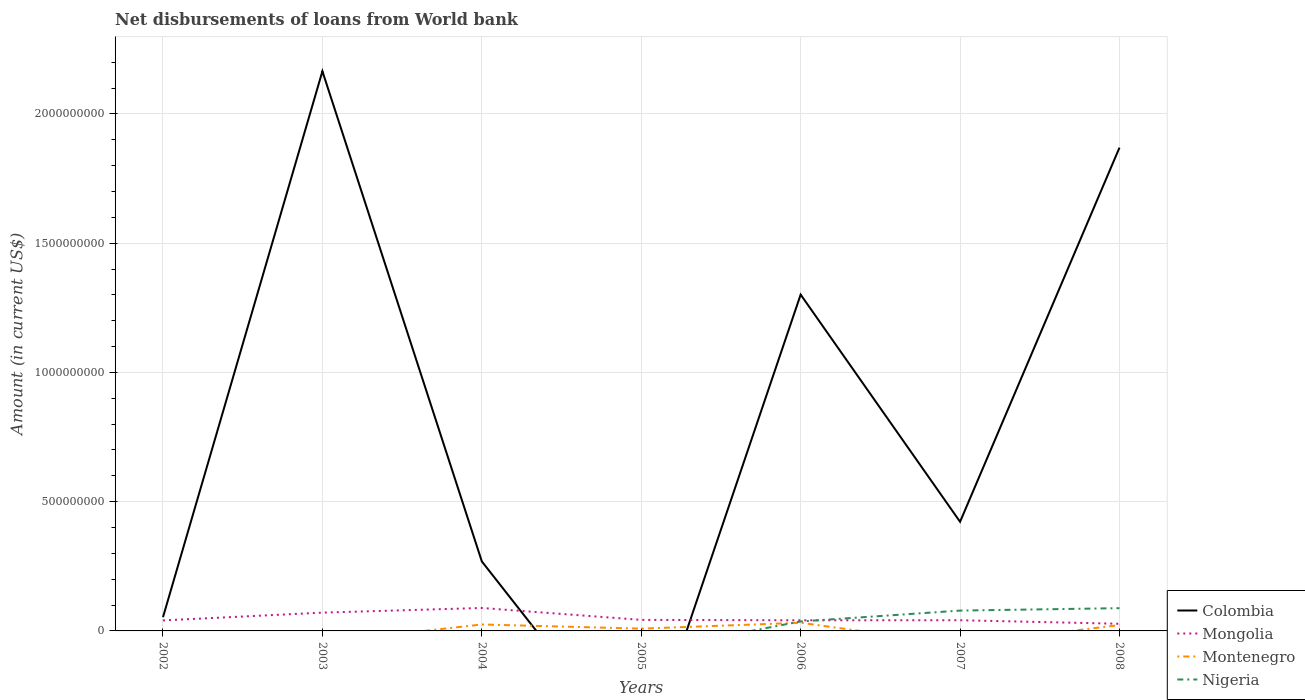Is the number of lines equal to the number of legend labels?
Ensure brevity in your answer.  No. What is the total amount of loan disbursed from World Bank in Colombia in the graph?
Your answer should be compact. -1.60e+09. What is the difference between the highest and the second highest amount of loan disbursed from World Bank in Nigeria?
Ensure brevity in your answer.  8.80e+07. What is the difference between the highest and the lowest amount of loan disbursed from World Bank in Colombia?
Your answer should be compact. 3. Are the values on the major ticks of Y-axis written in scientific E-notation?
Provide a succinct answer. No. Does the graph contain any zero values?
Make the answer very short. Yes. Does the graph contain grids?
Keep it short and to the point. Yes. Where does the legend appear in the graph?
Offer a terse response. Bottom right. How many legend labels are there?
Keep it short and to the point. 4. What is the title of the graph?
Give a very brief answer. Net disbursements of loans from World bank. Does "High income: OECD" appear as one of the legend labels in the graph?
Offer a terse response. No. What is the label or title of the X-axis?
Ensure brevity in your answer.  Years. What is the Amount (in current US$) in Colombia in 2002?
Your answer should be very brief. 5.33e+07. What is the Amount (in current US$) in Mongolia in 2002?
Offer a very short reply. 4.07e+07. What is the Amount (in current US$) in Nigeria in 2002?
Offer a very short reply. 0. What is the Amount (in current US$) of Colombia in 2003?
Offer a very short reply. 2.17e+09. What is the Amount (in current US$) in Mongolia in 2003?
Your answer should be very brief. 7.08e+07. What is the Amount (in current US$) in Nigeria in 2003?
Offer a very short reply. 0. What is the Amount (in current US$) in Colombia in 2004?
Provide a succinct answer. 2.69e+08. What is the Amount (in current US$) in Mongolia in 2004?
Your answer should be very brief. 8.88e+07. What is the Amount (in current US$) in Montenegro in 2004?
Ensure brevity in your answer.  2.50e+07. What is the Amount (in current US$) of Nigeria in 2004?
Give a very brief answer. 0. What is the Amount (in current US$) of Colombia in 2005?
Give a very brief answer. 0. What is the Amount (in current US$) in Mongolia in 2005?
Your answer should be very brief. 4.27e+07. What is the Amount (in current US$) in Montenegro in 2005?
Provide a succinct answer. 8.81e+06. What is the Amount (in current US$) in Nigeria in 2005?
Provide a succinct answer. 0. What is the Amount (in current US$) in Colombia in 2006?
Provide a short and direct response. 1.30e+09. What is the Amount (in current US$) of Mongolia in 2006?
Your response must be concise. 4.11e+07. What is the Amount (in current US$) in Montenegro in 2006?
Offer a very short reply. 3.16e+07. What is the Amount (in current US$) in Nigeria in 2006?
Ensure brevity in your answer.  3.66e+07. What is the Amount (in current US$) in Colombia in 2007?
Your answer should be very brief. 4.22e+08. What is the Amount (in current US$) of Mongolia in 2007?
Your answer should be compact. 4.14e+07. What is the Amount (in current US$) in Montenegro in 2007?
Provide a short and direct response. 0. What is the Amount (in current US$) of Nigeria in 2007?
Your answer should be compact. 7.87e+07. What is the Amount (in current US$) of Colombia in 2008?
Your answer should be compact. 1.87e+09. What is the Amount (in current US$) in Mongolia in 2008?
Ensure brevity in your answer.  2.77e+07. What is the Amount (in current US$) in Montenegro in 2008?
Provide a short and direct response. 2.27e+07. What is the Amount (in current US$) in Nigeria in 2008?
Offer a terse response. 8.80e+07. Across all years, what is the maximum Amount (in current US$) in Colombia?
Make the answer very short. 2.17e+09. Across all years, what is the maximum Amount (in current US$) of Mongolia?
Provide a succinct answer. 8.88e+07. Across all years, what is the maximum Amount (in current US$) of Montenegro?
Provide a succinct answer. 3.16e+07. Across all years, what is the maximum Amount (in current US$) of Nigeria?
Ensure brevity in your answer.  8.80e+07. Across all years, what is the minimum Amount (in current US$) in Mongolia?
Keep it short and to the point. 2.77e+07. Across all years, what is the minimum Amount (in current US$) of Montenegro?
Your answer should be very brief. 0. What is the total Amount (in current US$) of Colombia in the graph?
Ensure brevity in your answer.  6.08e+09. What is the total Amount (in current US$) of Mongolia in the graph?
Provide a short and direct response. 3.53e+08. What is the total Amount (in current US$) of Montenegro in the graph?
Offer a terse response. 8.80e+07. What is the total Amount (in current US$) in Nigeria in the graph?
Your response must be concise. 2.03e+08. What is the difference between the Amount (in current US$) in Colombia in 2002 and that in 2003?
Your answer should be very brief. -2.11e+09. What is the difference between the Amount (in current US$) of Mongolia in 2002 and that in 2003?
Provide a short and direct response. -3.01e+07. What is the difference between the Amount (in current US$) of Colombia in 2002 and that in 2004?
Provide a short and direct response. -2.16e+08. What is the difference between the Amount (in current US$) of Mongolia in 2002 and that in 2004?
Your answer should be compact. -4.81e+07. What is the difference between the Amount (in current US$) of Mongolia in 2002 and that in 2005?
Make the answer very short. -2.03e+06. What is the difference between the Amount (in current US$) in Colombia in 2002 and that in 2006?
Your response must be concise. -1.25e+09. What is the difference between the Amount (in current US$) of Mongolia in 2002 and that in 2006?
Your response must be concise. -4.18e+05. What is the difference between the Amount (in current US$) of Colombia in 2002 and that in 2007?
Offer a very short reply. -3.69e+08. What is the difference between the Amount (in current US$) of Mongolia in 2002 and that in 2007?
Keep it short and to the point. -6.66e+05. What is the difference between the Amount (in current US$) in Colombia in 2002 and that in 2008?
Your answer should be very brief. -1.82e+09. What is the difference between the Amount (in current US$) in Mongolia in 2002 and that in 2008?
Provide a short and direct response. 1.30e+07. What is the difference between the Amount (in current US$) of Colombia in 2003 and that in 2004?
Your answer should be compact. 1.90e+09. What is the difference between the Amount (in current US$) in Mongolia in 2003 and that in 2004?
Offer a terse response. -1.80e+07. What is the difference between the Amount (in current US$) in Mongolia in 2003 and that in 2005?
Ensure brevity in your answer.  2.80e+07. What is the difference between the Amount (in current US$) of Colombia in 2003 and that in 2006?
Your answer should be very brief. 8.64e+08. What is the difference between the Amount (in current US$) in Mongolia in 2003 and that in 2006?
Offer a very short reply. 2.96e+07. What is the difference between the Amount (in current US$) in Colombia in 2003 and that in 2007?
Make the answer very short. 1.74e+09. What is the difference between the Amount (in current US$) in Mongolia in 2003 and that in 2007?
Offer a terse response. 2.94e+07. What is the difference between the Amount (in current US$) in Colombia in 2003 and that in 2008?
Your answer should be compact. 2.96e+08. What is the difference between the Amount (in current US$) in Mongolia in 2003 and that in 2008?
Keep it short and to the point. 4.31e+07. What is the difference between the Amount (in current US$) in Mongolia in 2004 and that in 2005?
Offer a terse response. 4.61e+07. What is the difference between the Amount (in current US$) in Montenegro in 2004 and that in 2005?
Your answer should be compact. 1.61e+07. What is the difference between the Amount (in current US$) of Colombia in 2004 and that in 2006?
Offer a terse response. -1.03e+09. What is the difference between the Amount (in current US$) in Mongolia in 2004 and that in 2006?
Provide a short and direct response. 4.77e+07. What is the difference between the Amount (in current US$) of Montenegro in 2004 and that in 2006?
Provide a short and direct response. -6.62e+06. What is the difference between the Amount (in current US$) of Colombia in 2004 and that in 2007?
Keep it short and to the point. -1.53e+08. What is the difference between the Amount (in current US$) in Mongolia in 2004 and that in 2007?
Your response must be concise. 4.74e+07. What is the difference between the Amount (in current US$) in Colombia in 2004 and that in 2008?
Your response must be concise. -1.60e+09. What is the difference between the Amount (in current US$) in Mongolia in 2004 and that in 2008?
Ensure brevity in your answer.  6.11e+07. What is the difference between the Amount (in current US$) in Montenegro in 2004 and that in 2008?
Make the answer very short. 2.25e+06. What is the difference between the Amount (in current US$) of Mongolia in 2005 and that in 2006?
Give a very brief answer. 1.62e+06. What is the difference between the Amount (in current US$) of Montenegro in 2005 and that in 2006?
Keep it short and to the point. -2.28e+07. What is the difference between the Amount (in current US$) in Mongolia in 2005 and that in 2007?
Your response must be concise. 1.37e+06. What is the difference between the Amount (in current US$) in Mongolia in 2005 and that in 2008?
Offer a very short reply. 1.51e+07. What is the difference between the Amount (in current US$) in Montenegro in 2005 and that in 2008?
Your answer should be very brief. -1.39e+07. What is the difference between the Amount (in current US$) of Colombia in 2006 and that in 2007?
Your response must be concise. 8.79e+08. What is the difference between the Amount (in current US$) of Mongolia in 2006 and that in 2007?
Your answer should be very brief. -2.48e+05. What is the difference between the Amount (in current US$) in Nigeria in 2006 and that in 2007?
Make the answer very short. -4.21e+07. What is the difference between the Amount (in current US$) of Colombia in 2006 and that in 2008?
Offer a terse response. -5.69e+08. What is the difference between the Amount (in current US$) in Mongolia in 2006 and that in 2008?
Your response must be concise. 1.34e+07. What is the difference between the Amount (in current US$) of Montenegro in 2006 and that in 2008?
Offer a terse response. 8.87e+06. What is the difference between the Amount (in current US$) in Nigeria in 2006 and that in 2008?
Make the answer very short. -5.14e+07. What is the difference between the Amount (in current US$) in Colombia in 2007 and that in 2008?
Your answer should be very brief. -1.45e+09. What is the difference between the Amount (in current US$) in Mongolia in 2007 and that in 2008?
Make the answer very short. 1.37e+07. What is the difference between the Amount (in current US$) of Nigeria in 2007 and that in 2008?
Keep it short and to the point. -9.36e+06. What is the difference between the Amount (in current US$) in Colombia in 2002 and the Amount (in current US$) in Mongolia in 2003?
Offer a terse response. -1.74e+07. What is the difference between the Amount (in current US$) in Colombia in 2002 and the Amount (in current US$) in Mongolia in 2004?
Your answer should be very brief. -3.55e+07. What is the difference between the Amount (in current US$) of Colombia in 2002 and the Amount (in current US$) of Montenegro in 2004?
Make the answer very short. 2.84e+07. What is the difference between the Amount (in current US$) in Mongolia in 2002 and the Amount (in current US$) in Montenegro in 2004?
Make the answer very short. 1.57e+07. What is the difference between the Amount (in current US$) in Colombia in 2002 and the Amount (in current US$) in Mongolia in 2005?
Make the answer very short. 1.06e+07. What is the difference between the Amount (in current US$) in Colombia in 2002 and the Amount (in current US$) in Montenegro in 2005?
Offer a terse response. 4.45e+07. What is the difference between the Amount (in current US$) of Mongolia in 2002 and the Amount (in current US$) of Montenegro in 2005?
Give a very brief answer. 3.19e+07. What is the difference between the Amount (in current US$) in Colombia in 2002 and the Amount (in current US$) in Mongolia in 2006?
Your answer should be very brief. 1.22e+07. What is the difference between the Amount (in current US$) of Colombia in 2002 and the Amount (in current US$) of Montenegro in 2006?
Your answer should be compact. 2.17e+07. What is the difference between the Amount (in current US$) in Colombia in 2002 and the Amount (in current US$) in Nigeria in 2006?
Give a very brief answer. 1.67e+07. What is the difference between the Amount (in current US$) of Mongolia in 2002 and the Amount (in current US$) of Montenegro in 2006?
Keep it short and to the point. 9.12e+06. What is the difference between the Amount (in current US$) of Mongolia in 2002 and the Amount (in current US$) of Nigeria in 2006?
Keep it short and to the point. 4.08e+06. What is the difference between the Amount (in current US$) in Colombia in 2002 and the Amount (in current US$) in Mongolia in 2007?
Your answer should be compact. 1.20e+07. What is the difference between the Amount (in current US$) in Colombia in 2002 and the Amount (in current US$) in Nigeria in 2007?
Your response must be concise. -2.54e+07. What is the difference between the Amount (in current US$) in Mongolia in 2002 and the Amount (in current US$) in Nigeria in 2007?
Your answer should be compact. -3.80e+07. What is the difference between the Amount (in current US$) of Colombia in 2002 and the Amount (in current US$) of Mongolia in 2008?
Provide a short and direct response. 2.57e+07. What is the difference between the Amount (in current US$) of Colombia in 2002 and the Amount (in current US$) of Montenegro in 2008?
Keep it short and to the point. 3.06e+07. What is the difference between the Amount (in current US$) in Colombia in 2002 and the Amount (in current US$) in Nigeria in 2008?
Provide a succinct answer. -3.47e+07. What is the difference between the Amount (in current US$) in Mongolia in 2002 and the Amount (in current US$) in Montenegro in 2008?
Your answer should be compact. 1.80e+07. What is the difference between the Amount (in current US$) of Mongolia in 2002 and the Amount (in current US$) of Nigeria in 2008?
Your response must be concise. -4.74e+07. What is the difference between the Amount (in current US$) in Colombia in 2003 and the Amount (in current US$) in Mongolia in 2004?
Keep it short and to the point. 2.08e+09. What is the difference between the Amount (in current US$) of Colombia in 2003 and the Amount (in current US$) of Montenegro in 2004?
Provide a succinct answer. 2.14e+09. What is the difference between the Amount (in current US$) in Mongolia in 2003 and the Amount (in current US$) in Montenegro in 2004?
Your response must be concise. 4.58e+07. What is the difference between the Amount (in current US$) in Colombia in 2003 and the Amount (in current US$) in Mongolia in 2005?
Your answer should be very brief. 2.12e+09. What is the difference between the Amount (in current US$) of Colombia in 2003 and the Amount (in current US$) of Montenegro in 2005?
Make the answer very short. 2.16e+09. What is the difference between the Amount (in current US$) in Mongolia in 2003 and the Amount (in current US$) in Montenegro in 2005?
Keep it short and to the point. 6.20e+07. What is the difference between the Amount (in current US$) in Colombia in 2003 and the Amount (in current US$) in Mongolia in 2006?
Provide a short and direct response. 2.12e+09. What is the difference between the Amount (in current US$) of Colombia in 2003 and the Amount (in current US$) of Montenegro in 2006?
Your answer should be very brief. 2.13e+09. What is the difference between the Amount (in current US$) in Colombia in 2003 and the Amount (in current US$) in Nigeria in 2006?
Provide a succinct answer. 2.13e+09. What is the difference between the Amount (in current US$) of Mongolia in 2003 and the Amount (in current US$) of Montenegro in 2006?
Keep it short and to the point. 3.92e+07. What is the difference between the Amount (in current US$) of Mongolia in 2003 and the Amount (in current US$) of Nigeria in 2006?
Your answer should be very brief. 3.41e+07. What is the difference between the Amount (in current US$) of Colombia in 2003 and the Amount (in current US$) of Mongolia in 2007?
Your response must be concise. 2.12e+09. What is the difference between the Amount (in current US$) of Colombia in 2003 and the Amount (in current US$) of Nigeria in 2007?
Your answer should be very brief. 2.09e+09. What is the difference between the Amount (in current US$) of Mongolia in 2003 and the Amount (in current US$) of Nigeria in 2007?
Make the answer very short. -7.93e+06. What is the difference between the Amount (in current US$) of Colombia in 2003 and the Amount (in current US$) of Mongolia in 2008?
Provide a short and direct response. 2.14e+09. What is the difference between the Amount (in current US$) of Colombia in 2003 and the Amount (in current US$) of Montenegro in 2008?
Keep it short and to the point. 2.14e+09. What is the difference between the Amount (in current US$) in Colombia in 2003 and the Amount (in current US$) in Nigeria in 2008?
Your response must be concise. 2.08e+09. What is the difference between the Amount (in current US$) in Mongolia in 2003 and the Amount (in current US$) in Montenegro in 2008?
Provide a short and direct response. 4.81e+07. What is the difference between the Amount (in current US$) in Mongolia in 2003 and the Amount (in current US$) in Nigeria in 2008?
Offer a very short reply. -1.73e+07. What is the difference between the Amount (in current US$) in Colombia in 2004 and the Amount (in current US$) in Mongolia in 2005?
Give a very brief answer. 2.26e+08. What is the difference between the Amount (in current US$) of Colombia in 2004 and the Amount (in current US$) of Montenegro in 2005?
Your answer should be compact. 2.60e+08. What is the difference between the Amount (in current US$) in Mongolia in 2004 and the Amount (in current US$) in Montenegro in 2005?
Offer a very short reply. 8.00e+07. What is the difference between the Amount (in current US$) of Colombia in 2004 and the Amount (in current US$) of Mongolia in 2006?
Offer a terse response. 2.28e+08. What is the difference between the Amount (in current US$) in Colombia in 2004 and the Amount (in current US$) in Montenegro in 2006?
Offer a very short reply. 2.37e+08. What is the difference between the Amount (in current US$) in Colombia in 2004 and the Amount (in current US$) in Nigeria in 2006?
Keep it short and to the point. 2.32e+08. What is the difference between the Amount (in current US$) in Mongolia in 2004 and the Amount (in current US$) in Montenegro in 2006?
Give a very brief answer. 5.72e+07. What is the difference between the Amount (in current US$) of Mongolia in 2004 and the Amount (in current US$) of Nigeria in 2006?
Keep it short and to the point. 5.22e+07. What is the difference between the Amount (in current US$) of Montenegro in 2004 and the Amount (in current US$) of Nigeria in 2006?
Provide a succinct answer. -1.17e+07. What is the difference between the Amount (in current US$) of Colombia in 2004 and the Amount (in current US$) of Mongolia in 2007?
Keep it short and to the point. 2.28e+08. What is the difference between the Amount (in current US$) in Colombia in 2004 and the Amount (in current US$) in Nigeria in 2007?
Your answer should be very brief. 1.90e+08. What is the difference between the Amount (in current US$) of Mongolia in 2004 and the Amount (in current US$) of Nigeria in 2007?
Provide a short and direct response. 1.01e+07. What is the difference between the Amount (in current US$) of Montenegro in 2004 and the Amount (in current US$) of Nigeria in 2007?
Ensure brevity in your answer.  -5.37e+07. What is the difference between the Amount (in current US$) of Colombia in 2004 and the Amount (in current US$) of Mongolia in 2008?
Provide a succinct answer. 2.41e+08. What is the difference between the Amount (in current US$) in Colombia in 2004 and the Amount (in current US$) in Montenegro in 2008?
Offer a terse response. 2.46e+08. What is the difference between the Amount (in current US$) in Colombia in 2004 and the Amount (in current US$) in Nigeria in 2008?
Offer a very short reply. 1.81e+08. What is the difference between the Amount (in current US$) in Mongolia in 2004 and the Amount (in current US$) in Montenegro in 2008?
Make the answer very short. 6.61e+07. What is the difference between the Amount (in current US$) of Mongolia in 2004 and the Amount (in current US$) of Nigeria in 2008?
Your answer should be compact. 7.46e+05. What is the difference between the Amount (in current US$) of Montenegro in 2004 and the Amount (in current US$) of Nigeria in 2008?
Offer a terse response. -6.31e+07. What is the difference between the Amount (in current US$) of Mongolia in 2005 and the Amount (in current US$) of Montenegro in 2006?
Make the answer very short. 1.12e+07. What is the difference between the Amount (in current US$) of Mongolia in 2005 and the Amount (in current US$) of Nigeria in 2006?
Your answer should be compact. 6.12e+06. What is the difference between the Amount (in current US$) in Montenegro in 2005 and the Amount (in current US$) in Nigeria in 2006?
Your answer should be compact. -2.78e+07. What is the difference between the Amount (in current US$) in Mongolia in 2005 and the Amount (in current US$) in Nigeria in 2007?
Ensure brevity in your answer.  -3.60e+07. What is the difference between the Amount (in current US$) in Montenegro in 2005 and the Amount (in current US$) in Nigeria in 2007?
Provide a short and direct response. -6.99e+07. What is the difference between the Amount (in current US$) of Mongolia in 2005 and the Amount (in current US$) of Montenegro in 2008?
Keep it short and to the point. 2.00e+07. What is the difference between the Amount (in current US$) of Mongolia in 2005 and the Amount (in current US$) of Nigeria in 2008?
Offer a very short reply. -4.53e+07. What is the difference between the Amount (in current US$) of Montenegro in 2005 and the Amount (in current US$) of Nigeria in 2008?
Give a very brief answer. -7.92e+07. What is the difference between the Amount (in current US$) in Colombia in 2006 and the Amount (in current US$) in Mongolia in 2007?
Give a very brief answer. 1.26e+09. What is the difference between the Amount (in current US$) of Colombia in 2006 and the Amount (in current US$) of Nigeria in 2007?
Offer a very short reply. 1.22e+09. What is the difference between the Amount (in current US$) in Mongolia in 2006 and the Amount (in current US$) in Nigeria in 2007?
Give a very brief answer. -3.76e+07. What is the difference between the Amount (in current US$) of Montenegro in 2006 and the Amount (in current US$) of Nigeria in 2007?
Your response must be concise. -4.71e+07. What is the difference between the Amount (in current US$) in Colombia in 2006 and the Amount (in current US$) in Mongolia in 2008?
Your response must be concise. 1.27e+09. What is the difference between the Amount (in current US$) in Colombia in 2006 and the Amount (in current US$) in Montenegro in 2008?
Keep it short and to the point. 1.28e+09. What is the difference between the Amount (in current US$) in Colombia in 2006 and the Amount (in current US$) in Nigeria in 2008?
Provide a short and direct response. 1.21e+09. What is the difference between the Amount (in current US$) of Mongolia in 2006 and the Amount (in current US$) of Montenegro in 2008?
Your answer should be compact. 1.84e+07. What is the difference between the Amount (in current US$) in Mongolia in 2006 and the Amount (in current US$) in Nigeria in 2008?
Keep it short and to the point. -4.69e+07. What is the difference between the Amount (in current US$) of Montenegro in 2006 and the Amount (in current US$) of Nigeria in 2008?
Your answer should be compact. -5.65e+07. What is the difference between the Amount (in current US$) in Colombia in 2007 and the Amount (in current US$) in Mongolia in 2008?
Make the answer very short. 3.95e+08. What is the difference between the Amount (in current US$) of Colombia in 2007 and the Amount (in current US$) of Montenegro in 2008?
Keep it short and to the point. 4.00e+08. What is the difference between the Amount (in current US$) in Colombia in 2007 and the Amount (in current US$) in Nigeria in 2008?
Your answer should be compact. 3.34e+08. What is the difference between the Amount (in current US$) in Mongolia in 2007 and the Amount (in current US$) in Montenegro in 2008?
Your answer should be very brief. 1.87e+07. What is the difference between the Amount (in current US$) in Mongolia in 2007 and the Amount (in current US$) in Nigeria in 2008?
Make the answer very short. -4.67e+07. What is the average Amount (in current US$) of Colombia per year?
Provide a short and direct response. 8.69e+08. What is the average Amount (in current US$) of Mongolia per year?
Your response must be concise. 5.04e+07. What is the average Amount (in current US$) in Montenegro per year?
Give a very brief answer. 1.26e+07. What is the average Amount (in current US$) in Nigeria per year?
Your answer should be compact. 2.90e+07. In the year 2002, what is the difference between the Amount (in current US$) of Colombia and Amount (in current US$) of Mongolia?
Offer a terse response. 1.26e+07. In the year 2003, what is the difference between the Amount (in current US$) of Colombia and Amount (in current US$) of Mongolia?
Offer a very short reply. 2.09e+09. In the year 2004, what is the difference between the Amount (in current US$) in Colombia and Amount (in current US$) in Mongolia?
Your answer should be compact. 1.80e+08. In the year 2004, what is the difference between the Amount (in current US$) in Colombia and Amount (in current US$) in Montenegro?
Offer a terse response. 2.44e+08. In the year 2004, what is the difference between the Amount (in current US$) in Mongolia and Amount (in current US$) in Montenegro?
Offer a very short reply. 6.38e+07. In the year 2005, what is the difference between the Amount (in current US$) in Mongolia and Amount (in current US$) in Montenegro?
Offer a very short reply. 3.39e+07. In the year 2006, what is the difference between the Amount (in current US$) in Colombia and Amount (in current US$) in Mongolia?
Ensure brevity in your answer.  1.26e+09. In the year 2006, what is the difference between the Amount (in current US$) in Colombia and Amount (in current US$) in Montenegro?
Make the answer very short. 1.27e+09. In the year 2006, what is the difference between the Amount (in current US$) in Colombia and Amount (in current US$) in Nigeria?
Your answer should be very brief. 1.26e+09. In the year 2006, what is the difference between the Amount (in current US$) of Mongolia and Amount (in current US$) of Montenegro?
Your answer should be compact. 9.54e+06. In the year 2006, what is the difference between the Amount (in current US$) of Mongolia and Amount (in current US$) of Nigeria?
Provide a succinct answer. 4.50e+06. In the year 2006, what is the difference between the Amount (in current US$) in Montenegro and Amount (in current US$) in Nigeria?
Provide a short and direct response. -5.04e+06. In the year 2007, what is the difference between the Amount (in current US$) of Colombia and Amount (in current US$) of Mongolia?
Give a very brief answer. 3.81e+08. In the year 2007, what is the difference between the Amount (in current US$) in Colombia and Amount (in current US$) in Nigeria?
Your response must be concise. 3.44e+08. In the year 2007, what is the difference between the Amount (in current US$) in Mongolia and Amount (in current US$) in Nigeria?
Offer a very short reply. -3.73e+07. In the year 2008, what is the difference between the Amount (in current US$) of Colombia and Amount (in current US$) of Mongolia?
Offer a terse response. 1.84e+09. In the year 2008, what is the difference between the Amount (in current US$) of Colombia and Amount (in current US$) of Montenegro?
Give a very brief answer. 1.85e+09. In the year 2008, what is the difference between the Amount (in current US$) of Colombia and Amount (in current US$) of Nigeria?
Give a very brief answer. 1.78e+09. In the year 2008, what is the difference between the Amount (in current US$) of Mongolia and Amount (in current US$) of Montenegro?
Provide a succinct answer. 4.96e+06. In the year 2008, what is the difference between the Amount (in current US$) of Mongolia and Amount (in current US$) of Nigeria?
Give a very brief answer. -6.04e+07. In the year 2008, what is the difference between the Amount (in current US$) in Montenegro and Amount (in current US$) in Nigeria?
Offer a very short reply. -6.53e+07. What is the ratio of the Amount (in current US$) of Colombia in 2002 to that in 2003?
Give a very brief answer. 0.02. What is the ratio of the Amount (in current US$) of Mongolia in 2002 to that in 2003?
Offer a very short reply. 0.58. What is the ratio of the Amount (in current US$) of Colombia in 2002 to that in 2004?
Give a very brief answer. 0.2. What is the ratio of the Amount (in current US$) of Mongolia in 2002 to that in 2004?
Provide a short and direct response. 0.46. What is the ratio of the Amount (in current US$) of Colombia in 2002 to that in 2006?
Ensure brevity in your answer.  0.04. What is the ratio of the Amount (in current US$) of Mongolia in 2002 to that in 2006?
Give a very brief answer. 0.99. What is the ratio of the Amount (in current US$) of Colombia in 2002 to that in 2007?
Your answer should be compact. 0.13. What is the ratio of the Amount (in current US$) of Mongolia in 2002 to that in 2007?
Offer a very short reply. 0.98. What is the ratio of the Amount (in current US$) in Colombia in 2002 to that in 2008?
Offer a very short reply. 0.03. What is the ratio of the Amount (in current US$) of Mongolia in 2002 to that in 2008?
Provide a succinct answer. 1.47. What is the ratio of the Amount (in current US$) in Colombia in 2003 to that in 2004?
Provide a succinct answer. 8.05. What is the ratio of the Amount (in current US$) in Mongolia in 2003 to that in 2004?
Offer a terse response. 0.8. What is the ratio of the Amount (in current US$) in Mongolia in 2003 to that in 2005?
Keep it short and to the point. 1.66. What is the ratio of the Amount (in current US$) in Colombia in 2003 to that in 2006?
Provide a succinct answer. 1.66. What is the ratio of the Amount (in current US$) of Mongolia in 2003 to that in 2006?
Your answer should be compact. 1.72. What is the ratio of the Amount (in current US$) of Colombia in 2003 to that in 2007?
Ensure brevity in your answer.  5.13. What is the ratio of the Amount (in current US$) in Mongolia in 2003 to that in 2007?
Make the answer very short. 1.71. What is the ratio of the Amount (in current US$) in Colombia in 2003 to that in 2008?
Your answer should be very brief. 1.16. What is the ratio of the Amount (in current US$) of Mongolia in 2003 to that in 2008?
Give a very brief answer. 2.56. What is the ratio of the Amount (in current US$) of Mongolia in 2004 to that in 2005?
Ensure brevity in your answer.  2.08. What is the ratio of the Amount (in current US$) in Montenegro in 2004 to that in 2005?
Ensure brevity in your answer.  2.83. What is the ratio of the Amount (in current US$) in Colombia in 2004 to that in 2006?
Your response must be concise. 0.21. What is the ratio of the Amount (in current US$) of Mongolia in 2004 to that in 2006?
Make the answer very short. 2.16. What is the ratio of the Amount (in current US$) of Montenegro in 2004 to that in 2006?
Your answer should be compact. 0.79. What is the ratio of the Amount (in current US$) in Colombia in 2004 to that in 2007?
Your answer should be very brief. 0.64. What is the ratio of the Amount (in current US$) in Mongolia in 2004 to that in 2007?
Offer a very short reply. 2.15. What is the ratio of the Amount (in current US$) of Colombia in 2004 to that in 2008?
Provide a short and direct response. 0.14. What is the ratio of the Amount (in current US$) in Mongolia in 2004 to that in 2008?
Provide a succinct answer. 3.21. What is the ratio of the Amount (in current US$) of Montenegro in 2004 to that in 2008?
Give a very brief answer. 1.1. What is the ratio of the Amount (in current US$) in Mongolia in 2005 to that in 2006?
Your answer should be very brief. 1.04. What is the ratio of the Amount (in current US$) in Montenegro in 2005 to that in 2006?
Keep it short and to the point. 0.28. What is the ratio of the Amount (in current US$) in Mongolia in 2005 to that in 2007?
Your answer should be very brief. 1.03. What is the ratio of the Amount (in current US$) of Mongolia in 2005 to that in 2008?
Ensure brevity in your answer.  1.54. What is the ratio of the Amount (in current US$) of Montenegro in 2005 to that in 2008?
Provide a short and direct response. 0.39. What is the ratio of the Amount (in current US$) in Colombia in 2006 to that in 2007?
Ensure brevity in your answer.  3.08. What is the ratio of the Amount (in current US$) of Mongolia in 2006 to that in 2007?
Your answer should be compact. 0.99. What is the ratio of the Amount (in current US$) in Nigeria in 2006 to that in 2007?
Offer a very short reply. 0.47. What is the ratio of the Amount (in current US$) in Colombia in 2006 to that in 2008?
Make the answer very short. 0.7. What is the ratio of the Amount (in current US$) in Mongolia in 2006 to that in 2008?
Your answer should be very brief. 1.49. What is the ratio of the Amount (in current US$) in Montenegro in 2006 to that in 2008?
Give a very brief answer. 1.39. What is the ratio of the Amount (in current US$) in Nigeria in 2006 to that in 2008?
Provide a short and direct response. 0.42. What is the ratio of the Amount (in current US$) of Colombia in 2007 to that in 2008?
Offer a very short reply. 0.23. What is the ratio of the Amount (in current US$) of Mongolia in 2007 to that in 2008?
Your answer should be very brief. 1.5. What is the ratio of the Amount (in current US$) in Nigeria in 2007 to that in 2008?
Your answer should be very brief. 0.89. What is the difference between the highest and the second highest Amount (in current US$) of Colombia?
Offer a terse response. 2.96e+08. What is the difference between the highest and the second highest Amount (in current US$) in Mongolia?
Offer a terse response. 1.80e+07. What is the difference between the highest and the second highest Amount (in current US$) in Montenegro?
Keep it short and to the point. 6.62e+06. What is the difference between the highest and the second highest Amount (in current US$) of Nigeria?
Provide a short and direct response. 9.36e+06. What is the difference between the highest and the lowest Amount (in current US$) in Colombia?
Your answer should be compact. 2.17e+09. What is the difference between the highest and the lowest Amount (in current US$) in Mongolia?
Offer a very short reply. 6.11e+07. What is the difference between the highest and the lowest Amount (in current US$) in Montenegro?
Your answer should be very brief. 3.16e+07. What is the difference between the highest and the lowest Amount (in current US$) of Nigeria?
Your response must be concise. 8.80e+07. 